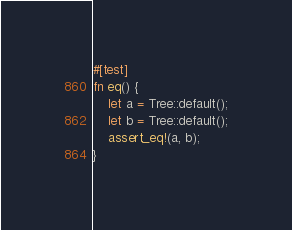Convert code to text. <code><loc_0><loc_0><loc_500><loc_500><_Rust_>
#[test]
fn eq() {
    let a = Tree::default();
    let b = Tree::default();
    assert_eq!(a, b);
}
</code> 